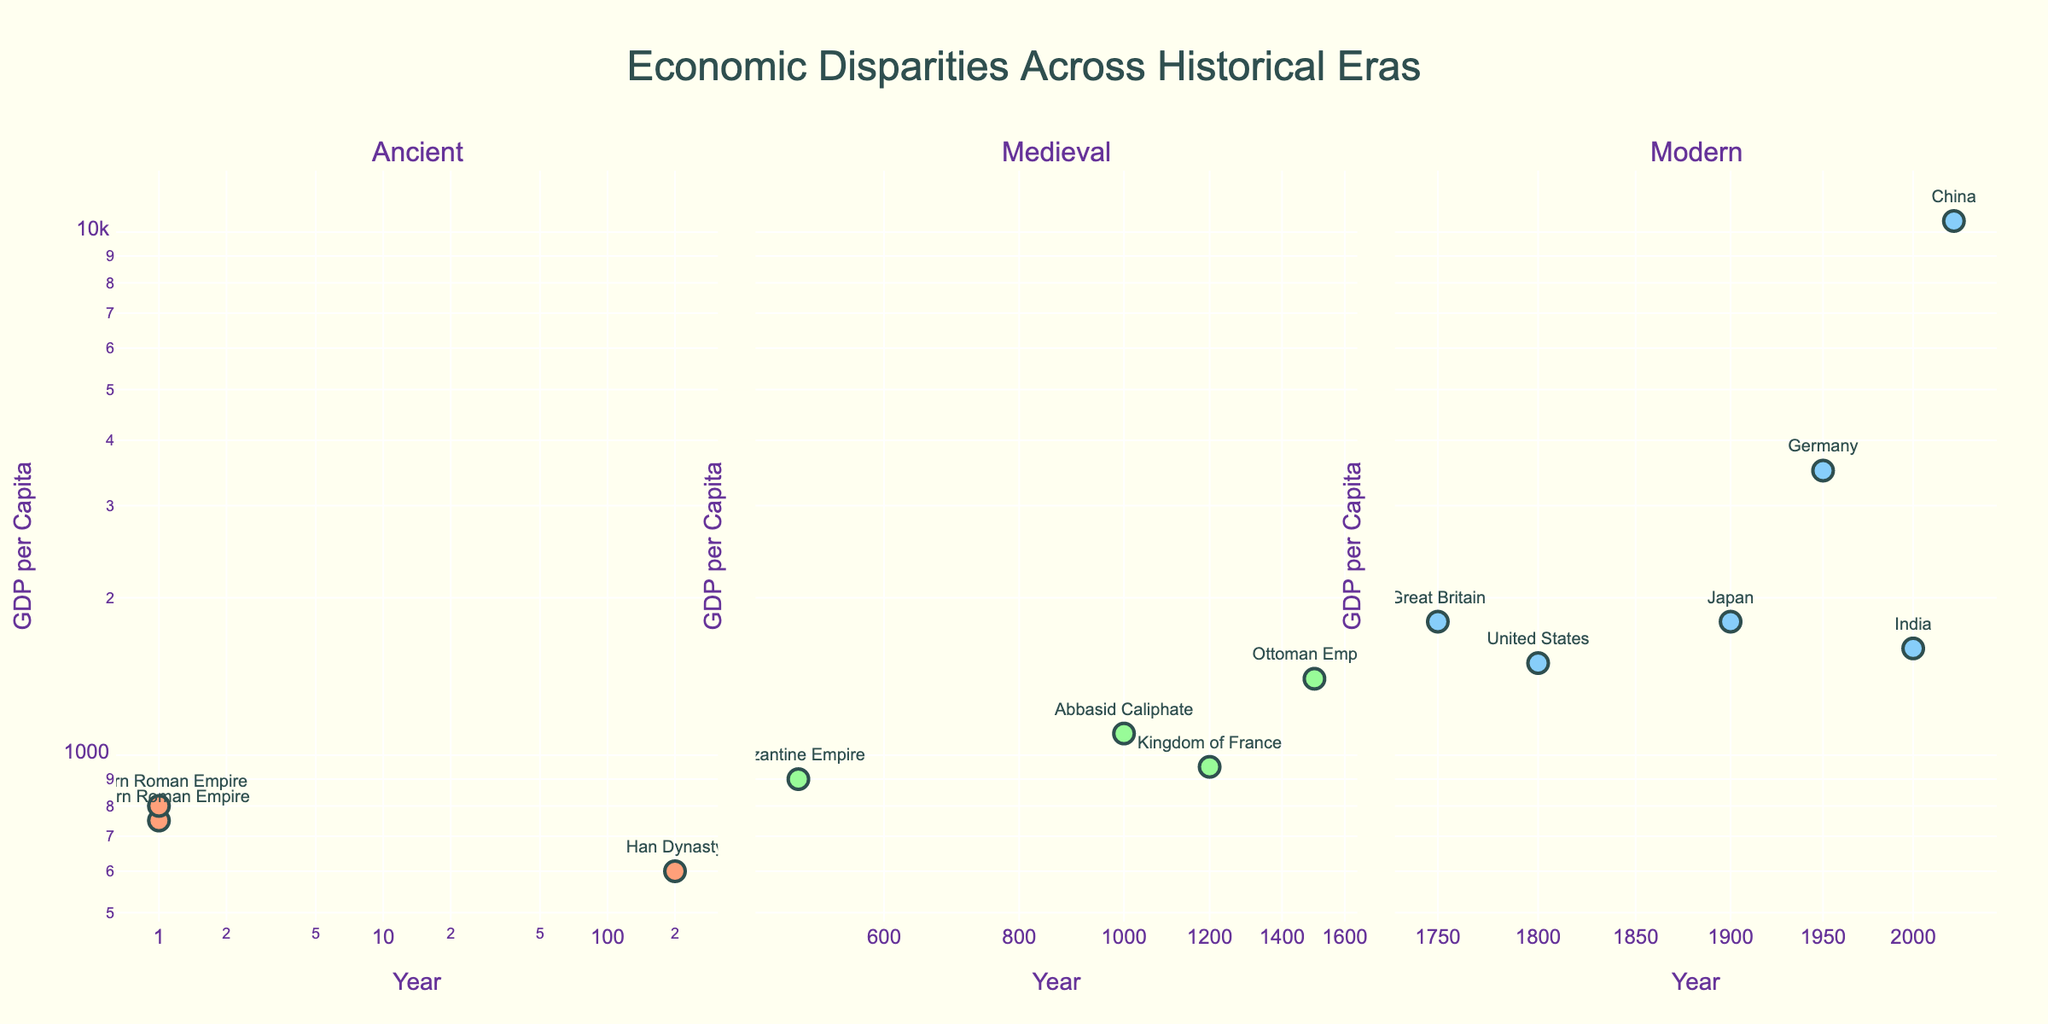What is the title of the figure? The title is usually placed at the top of the figure. Here, it reads 'Economic Disparities Across Historical Eras'.
Answer: Economic Disparities Across Historical Eras Which period has the highest GDP per capita? To find the period with the highest GDP per capita, we look for the highest point on the y-axis for each subplot. In the Modern period, China has the highest GDP per capita of 10500.
Answer: Modern In the Ancient era, which region had the higher GDP per capita, the Western Roman Empire or the Eastern Roman Empire? By comparing the markers for the Western and Eastern Roman Empires in the Ancient era subplot, the Eastern Roman Empire has a higher GDP per capita (800) than the Western Roman Empire (750).
Answer: Eastern Roman Empire How many regions are represented in the Medieval period subplot? Count the number of unique markers in the Medieval period subplot. The regions are the Byzantine Empire, Abbasid Caliphate, Kingdom of France, and Ottoman Empire, totaling 4.
Answer: 4 What is the GDP per capita of the Ottoman Empire in the Medieval period? Locate the marker for the Ottoman Empire in the Medieval period subplot; it reads a GDP per capita of 1400.
Answer: 1400 Did the GDP per capita of the United States increase or decrease from 1800 to 1900 in the Modern period? By reviewing the markers in the Modern period subplot, the GDP per capita for the United States was 1500 in 1800 and is absent for 1900, indicating no comparison can be made within the provided data.
Answer: N/A Which region had a GDP per capita of 3500 in the Modern period? Find the marker correspondingly in the Modern period subplot; Germany had a GDP per capita of 3500 in 1950.
Answer: Germany In which period do we see the most significant range in GDP per capita values? To determine this, compare the range between the minimum and maximum GDP per capita values in each subplot. The Modern period has the widest range from 1500 (U.S. in 1800) to 10500 (China in 2023).
Answer: Modern What is the color of the markers used for the Ancient period subplot? Identify the specific color used within the Ancient period subplot; the markers are a shade of red (#FFA07A).
Answer: Light Salmon What is the average GDP per capita in the Medieval period? To find the average, sum the data points for the Medieval period (900 + 1100 + 950 + 1400) = 4350 and divide by the number of points (4). The average GDP per capita for the Medieval period is 4350 / 4 = 1087.5.
Answer: 1087.5 